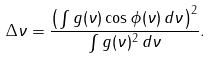<formula> <loc_0><loc_0><loc_500><loc_500>\Delta \nu = \frac { \left ( \int g ( \nu ) \cos \phi ( \nu ) \, d \nu \right ) ^ { 2 } } { \int g ( \nu ) ^ { 2 } \, d \nu } .</formula> 